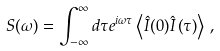Convert formula to latex. <formula><loc_0><loc_0><loc_500><loc_500>S ( \omega ) = \int _ { - \infty } ^ { \infty } d \tau e ^ { i \omega \tau } \left < \hat { I } ( 0 ) \hat { I } \left ( \tau \right ) \right > \, ,</formula> 